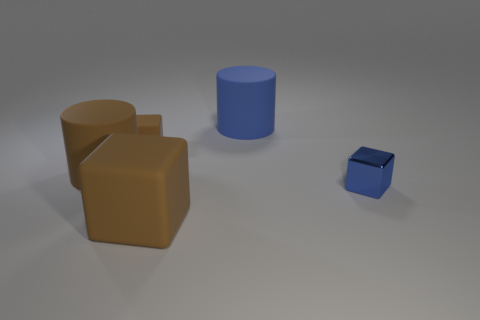Subtract all green cylinders. How many brown cubes are left? 2 Subtract all matte cubes. How many cubes are left? 1 Add 3 big gray objects. How many objects exist? 8 Subtract all cubes. How many objects are left? 2 Add 2 large blocks. How many large blocks exist? 3 Subtract 0 gray spheres. How many objects are left? 5 Subtract all purple shiny things. Subtract all metal objects. How many objects are left? 4 Add 1 big rubber cylinders. How many big rubber cylinders are left? 3 